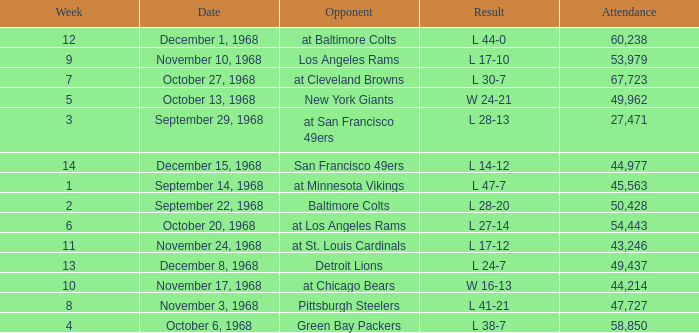Which Attendance has an Opponent of new york giants, and a Week smaller than 5? None. 